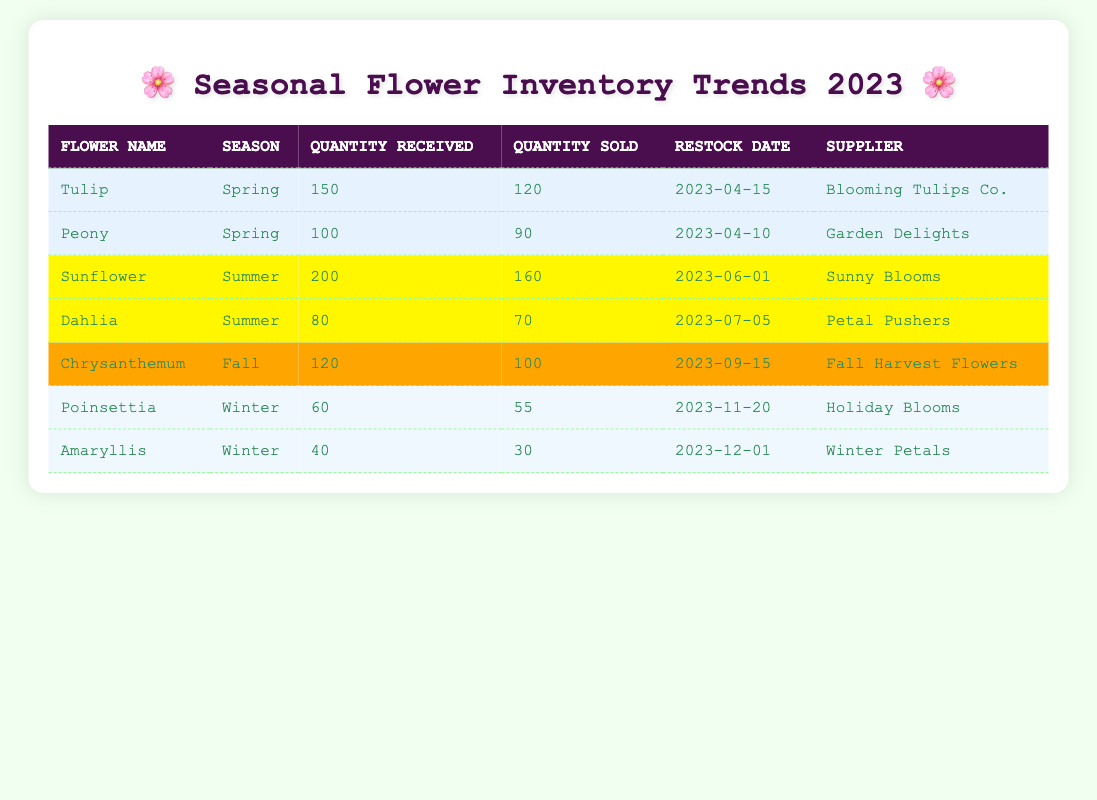What flower had the highest quantity received in Spring? The data shows that the Tulip received 150 units while the Peony received 100 units. Therefore, the Tulip has the highest quantity received in Spring.
Answer: Tulip How many Sunflowers were sold? According to the table, 160 Sunflowers were sold as indicated in the 'Quantity Sold' column for Sunflower.
Answer: 160 What is the total quantity of flowers received in Winter? The Poinsettia received 60 units, and the Amaryllis received 40 units. Summing these gives us 60 + 40 = 100. Thus, a total of 100 flowers were received in Winter.
Answer: 100 Did more Dahlias get sold than Poinsettias? The Dahlias sold 70 units while the Poinsettias sold 55 units, which shows that more Dahlias were sold.
Answer: Yes What is the average quantity of flowers sold for the Summer season? The Sunflower sold 160 and Dahlia sold 70. Summing these gives 160 + 70 = 230. There are 2 flowers, so the average is 230 / 2 = 115.
Answer: 115 Which supplier provided the most flowers in terms of quantity received? The Tulip received 150 units from Blooming Tulips Co., and the Sunflower received 200 from Sunny Blooms; therefore, Sunny Blooms provided the most quantity received.
Answer: Sunny Blooms Is it true that all flowers received in Fall were sold? Chrysanthemums received 120 units and sold 100 units, meaning 20 units were left unsold. Thus, not all flowers received in Fall were sold.
Answer: No Which flower had the least quantity sold in Winter? The Amaryllis sold 30 units while the Poinsettia sold 55 units. Therefore, the Amaryllis had the least quantity sold in Winter.
Answer: Amaryllis What percentage of Tulips received were sold? The Tulip received 150 units and sold 120 units. To find the percentage sold, we calculate (120 / 150) * 100 which equals 80%.
Answer: 80% 